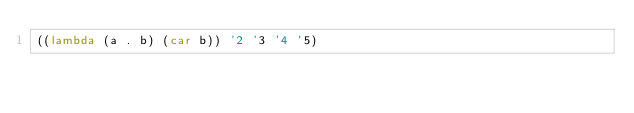<code> <loc_0><loc_0><loc_500><loc_500><_Scheme_>((lambda (a . b) (car b)) '2 '3 '4 '5)
</code> 